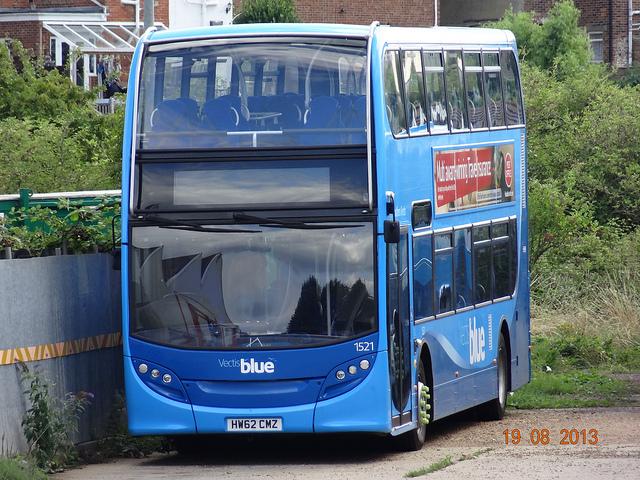Could people exit this bus right now?
Give a very brief answer. Yes. How many levels is the bus?
Concise answer only. 2. What color is the bus?
Concise answer only. Blue. 